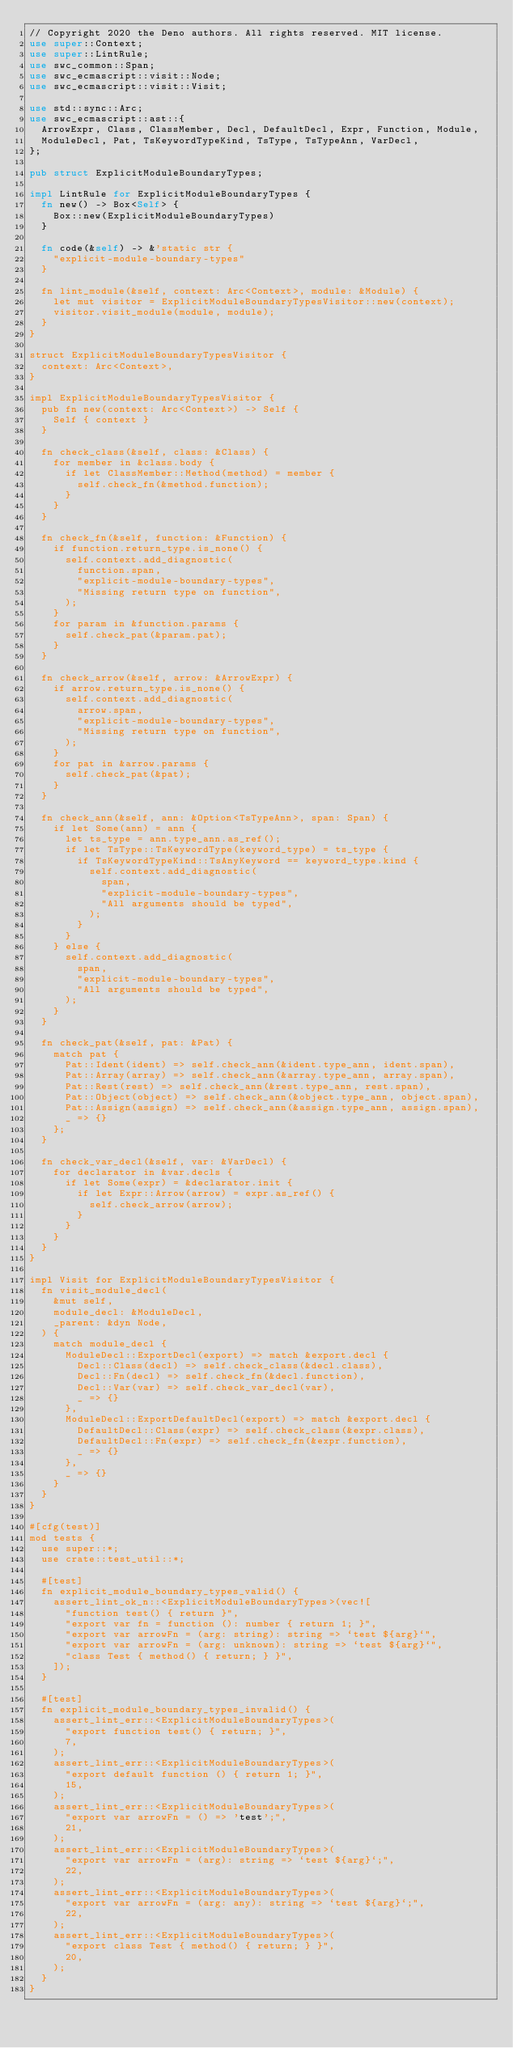Convert code to text. <code><loc_0><loc_0><loc_500><loc_500><_Rust_>// Copyright 2020 the Deno authors. All rights reserved. MIT license.
use super::Context;
use super::LintRule;
use swc_common::Span;
use swc_ecmascript::visit::Node;
use swc_ecmascript::visit::Visit;

use std::sync::Arc;
use swc_ecmascript::ast::{
  ArrowExpr, Class, ClassMember, Decl, DefaultDecl, Expr, Function, Module,
  ModuleDecl, Pat, TsKeywordTypeKind, TsType, TsTypeAnn, VarDecl,
};

pub struct ExplicitModuleBoundaryTypes;

impl LintRule for ExplicitModuleBoundaryTypes {
  fn new() -> Box<Self> {
    Box::new(ExplicitModuleBoundaryTypes)
  }

  fn code(&self) -> &'static str {
    "explicit-module-boundary-types"
  }

  fn lint_module(&self, context: Arc<Context>, module: &Module) {
    let mut visitor = ExplicitModuleBoundaryTypesVisitor::new(context);
    visitor.visit_module(module, module);
  }
}

struct ExplicitModuleBoundaryTypesVisitor {
  context: Arc<Context>,
}

impl ExplicitModuleBoundaryTypesVisitor {
  pub fn new(context: Arc<Context>) -> Self {
    Self { context }
  }

  fn check_class(&self, class: &Class) {
    for member in &class.body {
      if let ClassMember::Method(method) = member {
        self.check_fn(&method.function);
      }
    }
  }

  fn check_fn(&self, function: &Function) {
    if function.return_type.is_none() {
      self.context.add_diagnostic(
        function.span,
        "explicit-module-boundary-types",
        "Missing return type on function",
      );
    }
    for param in &function.params {
      self.check_pat(&param.pat);
    }
  }

  fn check_arrow(&self, arrow: &ArrowExpr) {
    if arrow.return_type.is_none() {
      self.context.add_diagnostic(
        arrow.span,
        "explicit-module-boundary-types",
        "Missing return type on function",
      );
    }
    for pat in &arrow.params {
      self.check_pat(&pat);
    }
  }

  fn check_ann(&self, ann: &Option<TsTypeAnn>, span: Span) {
    if let Some(ann) = ann {
      let ts_type = ann.type_ann.as_ref();
      if let TsType::TsKeywordType(keyword_type) = ts_type {
        if TsKeywordTypeKind::TsAnyKeyword == keyword_type.kind {
          self.context.add_diagnostic(
            span,
            "explicit-module-boundary-types",
            "All arguments should be typed",
          );
        }
      }
    } else {
      self.context.add_diagnostic(
        span,
        "explicit-module-boundary-types",
        "All arguments should be typed",
      );
    }
  }

  fn check_pat(&self, pat: &Pat) {
    match pat {
      Pat::Ident(ident) => self.check_ann(&ident.type_ann, ident.span),
      Pat::Array(array) => self.check_ann(&array.type_ann, array.span),
      Pat::Rest(rest) => self.check_ann(&rest.type_ann, rest.span),
      Pat::Object(object) => self.check_ann(&object.type_ann, object.span),
      Pat::Assign(assign) => self.check_ann(&assign.type_ann, assign.span),
      _ => {}
    };
  }

  fn check_var_decl(&self, var: &VarDecl) {
    for declarator in &var.decls {
      if let Some(expr) = &declarator.init {
        if let Expr::Arrow(arrow) = expr.as_ref() {
          self.check_arrow(arrow);
        }
      }
    }
  }
}

impl Visit for ExplicitModuleBoundaryTypesVisitor {
  fn visit_module_decl(
    &mut self,
    module_decl: &ModuleDecl,
    _parent: &dyn Node,
  ) {
    match module_decl {
      ModuleDecl::ExportDecl(export) => match &export.decl {
        Decl::Class(decl) => self.check_class(&decl.class),
        Decl::Fn(decl) => self.check_fn(&decl.function),
        Decl::Var(var) => self.check_var_decl(var),
        _ => {}
      },
      ModuleDecl::ExportDefaultDecl(export) => match &export.decl {
        DefaultDecl::Class(expr) => self.check_class(&expr.class),
        DefaultDecl::Fn(expr) => self.check_fn(&expr.function),
        _ => {}
      },
      _ => {}
    }
  }
}

#[cfg(test)]
mod tests {
  use super::*;
  use crate::test_util::*;

  #[test]
  fn explicit_module_boundary_types_valid() {
    assert_lint_ok_n::<ExplicitModuleBoundaryTypes>(vec![
      "function test() { return }",
      "export var fn = function (): number { return 1; }",
      "export var arrowFn = (arg: string): string => `test ${arg}`",
      "export var arrowFn = (arg: unknown): string => `test ${arg}`",
      "class Test { method() { return; } }",
    ]);
  }

  #[test]
  fn explicit_module_boundary_types_invalid() {
    assert_lint_err::<ExplicitModuleBoundaryTypes>(
      "export function test() { return; }",
      7,
    );
    assert_lint_err::<ExplicitModuleBoundaryTypes>(
      "export default function () { return 1; }",
      15,
    );
    assert_lint_err::<ExplicitModuleBoundaryTypes>(
      "export var arrowFn = () => 'test';",
      21,
    );
    assert_lint_err::<ExplicitModuleBoundaryTypes>(
      "export var arrowFn = (arg): string => `test ${arg}`;",
      22,
    );
    assert_lint_err::<ExplicitModuleBoundaryTypes>(
      "export var arrowFn = (arg: any): string => `test ${arg}`;",
      22,
    );
    assert_lint_err::<ExplicitModuleBoundaryTypes>(
      "export class Test { method() { return; } }",
      20,
    );
  }
}
</code> 